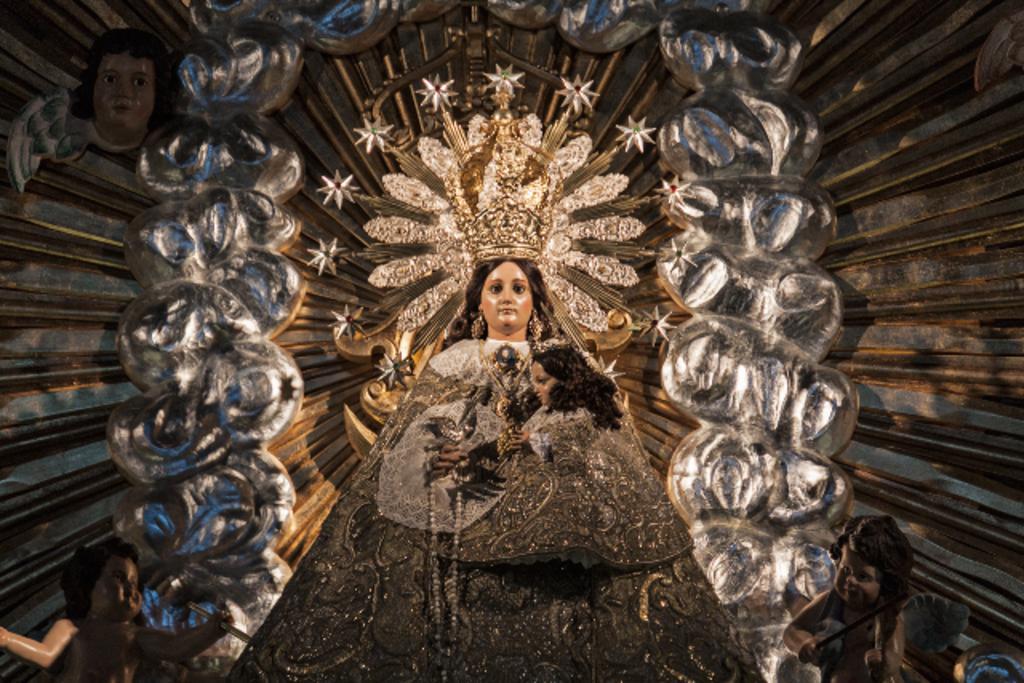Describe this image in one or two sentences. In this image we can see sculptures. 